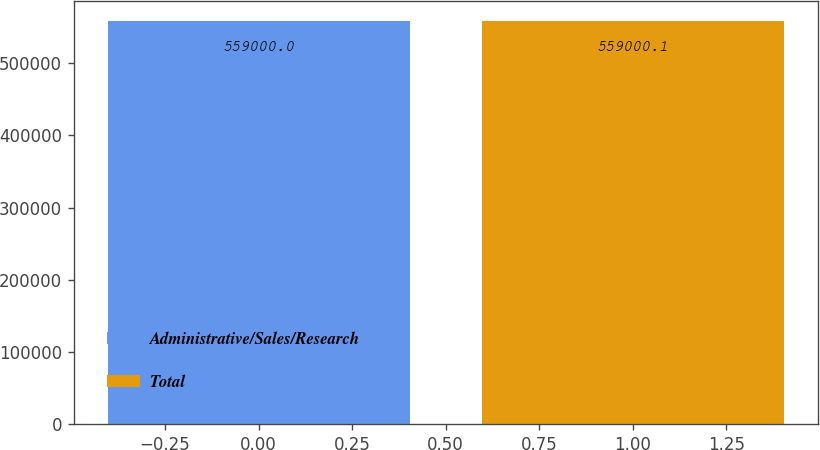Convert chart. <chart><loc_0><loc_0><loc_500><loc_500><bar_chart><fcel>Administrative/Sales/Research<fcel>Total<nl><fcel>559000<fcel>559000<nl></chart> 